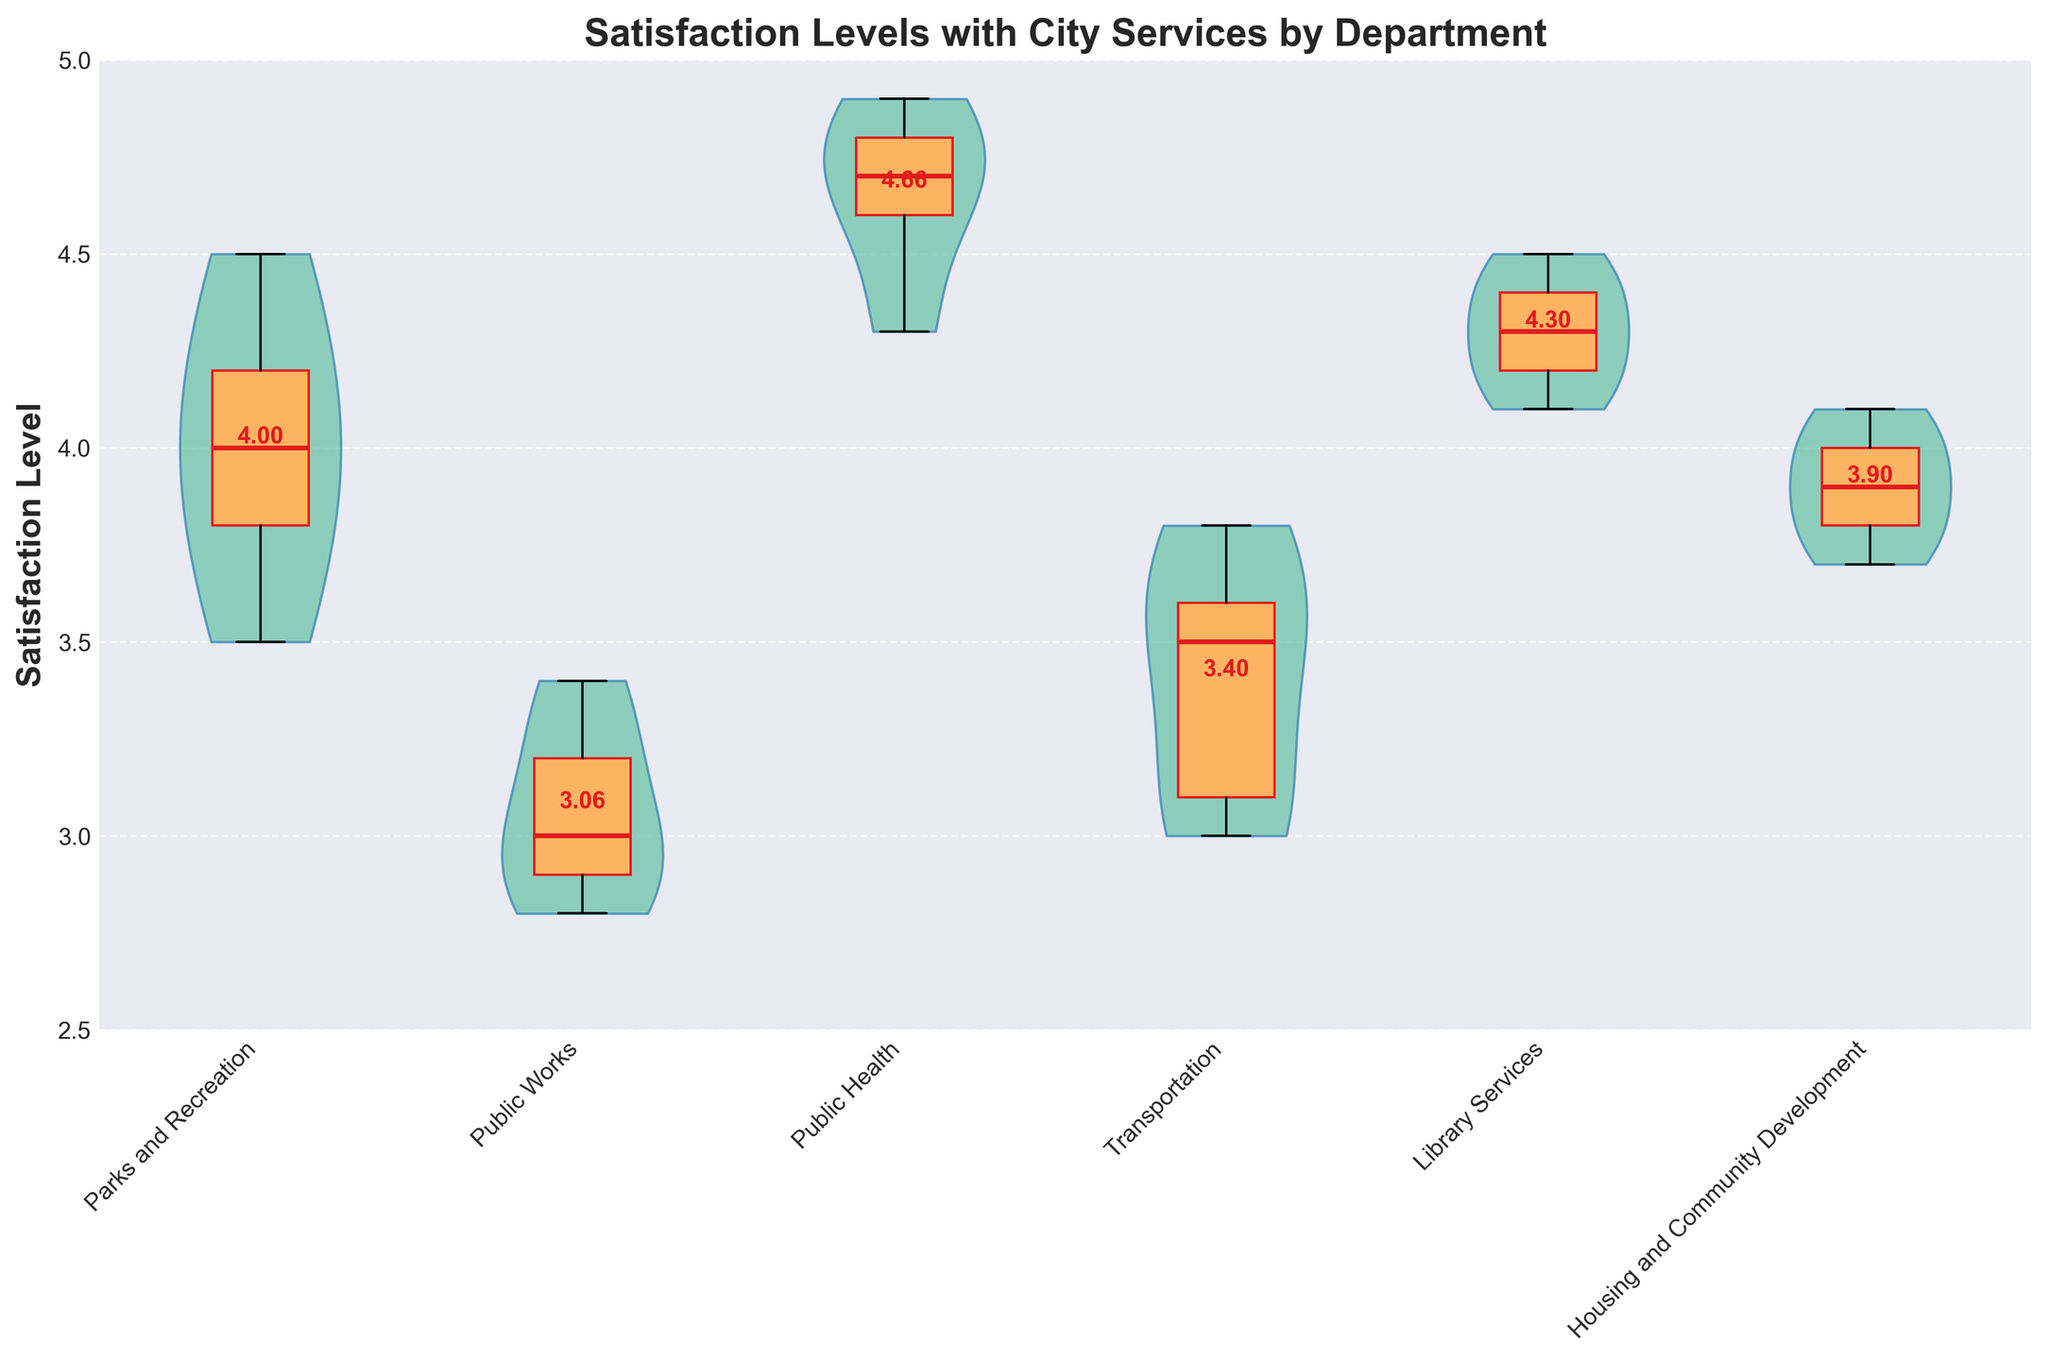What's the title of the chart? The title of the chart is usually placed at the top of the figure. By reading it, you can directly get what the chart aims to display.
Answer: Satisfaction Levels with City Services by Department What are the departments listed on the x-axis? The departments are the categories segmented along the x-axis. You can find them by reading the labels directly under the x-axis.
Answer: Parks and Recreation, Public Works, Public Health, Transportation, Library Services, Housing and Community Development What does the y-axis represent? The y-axis label indicates what is being measured or quantified in the chart. It is usually on the left side of the axis.
Answer: Satisfaction Level Which department has the highest average satisfaction level? To find the department with the highest average satisfaction, you can look at the mean values annotated within or above the violins.
Answer: Public Health What is the average satisfaction level for the Library Services department? By looking at the text annotation on the Library Services violin plot, you can directly find the mean value.
Answer: 4.30 Which department has the lowest median satisfaction level? Identify the median line within each violin plot (usually marked with a different color) and compare their positions. The lowest one will show the department with the lowest median.
Answer: Public Works How many departments have an average satisfaction level above 4.0? Count the number of mean annotations in the violin plots that are greater than 4.0.
Answer: 3 What is the range of satisfaction levels for the Transportation department? The range can be determined by looking at the spread of the violin plot from the lowest to the highest point and noting the minimum and maximum values.
Answer: 3.0 to 3.8 Are there more departments with an average satisfaction level above or below 4.0? Compare the number of departments where the mean value annotation is above 4.0 to those below 4.0.
Answer: More below 4.0 Which department shows the most variability in satisfaction levels? The department with the widest spread or the largest range in its violin plot indicates the most variability.
Answer: Public Works 